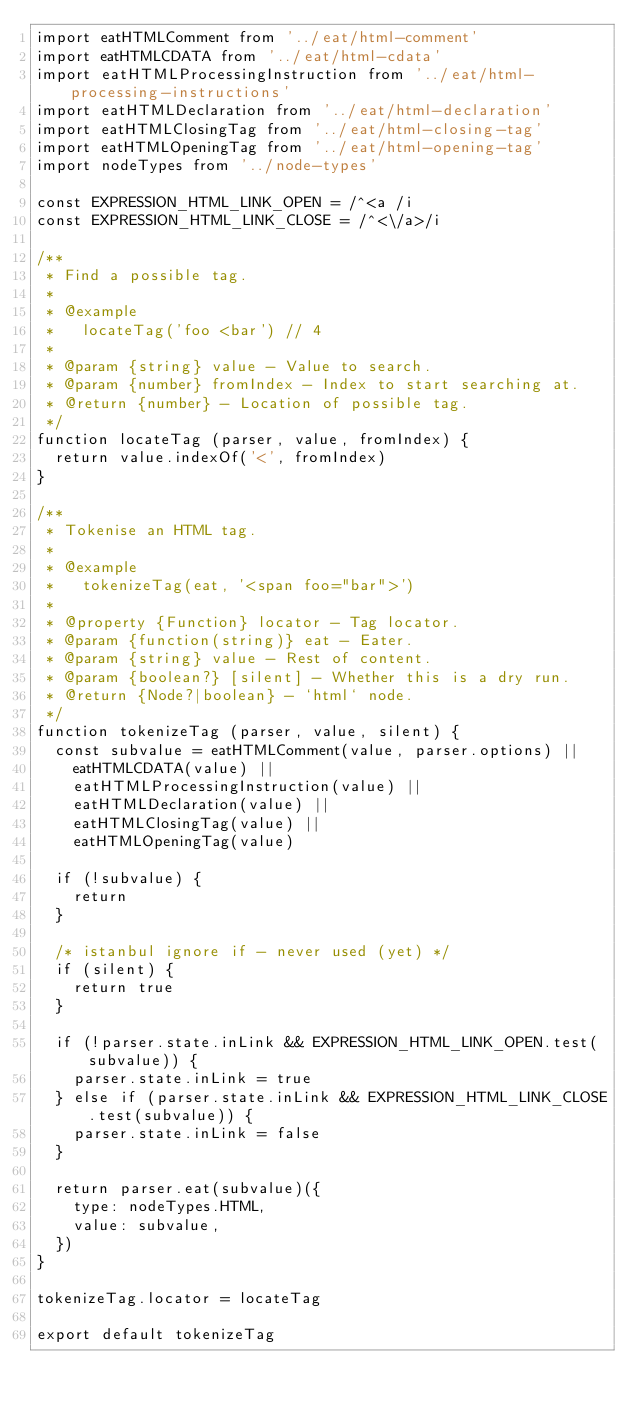<code> <loc_0><loc_0><loc_500><loc_500><_JavaScript_>import eatHTMLComment from '../eat/html-comment'
import eatHTMLCDATA from '../eat/html-cdata'
import eatHTMLProcessingInstruction from '../eat/html-processing-instructions'
import eatHTMLDeclaration from '../eat/html-declaration'
import eatHTMLClosingTag from '../eat/html-closing-tag'
import eatHTMLOpeningTag from '../eat/html-opening-tag'
import nodeTypes from '../node-types'

const EXPRESSION_HTML_LINK_OPEN = /^<a /i
const EXPRESSION_HTML_LINK_CLOSE = /^<\/a>/i

/**
 * Find a possible tag.
 *
 * @example
 *   locateTag('foo <bar') // 4
 *
 * @param {string} value - Value to search.
 * @param {number} fromIndex - Index to start searching at.
 * @return {number} - Location of possible tag.
 */
function locateTag (parser, value, fromIndex) {
  return value.indexOf('<', fromIndex)
}

/**
 * Tokenise an HTML tag.
 *
 * @example
 *   tokenizeTag(eat, '<span foo="bar">')
 *
 * @property {Function} locator - Tag locator.
 * @param {function(string)} eat - Eater.
 * @param {string} value - Rest of content.
 * @param {boolean?} [silent] - Whether this is a dry run.
 * @return {Node?|boolean} - `html` node.
 */
function tokenizeTag (parser, value, silent) {
  const subvalue = eatHTMLComment(value, parser.options) ||
    eatHTMLCDATA(value) ||
    eatHTMLProcessingInstruction(value) ||
    eatHTMLDeclaration(value) ||
    eatHTMLClosingTag(value) ||
    eatHTMLOpeningTag(value)

  if (!subvalue) {
    return
  }

  /* istanbul ignore if - never used (yet) */
  if (silent) {
    return true
  }

  if (!parser.state.inLink && EXPRESSION_HTML_LINK_OPEN.test(subvalue)) {
    parser.state.inLink = true
  } else if (parser.state.inLink && EXPRESSION_HTML_LINK_CLOSE.test(subvalue)) {
    parser.state.inLink = false
  }

  return parser.eat(subvalue)({
    type: nodeTypes.HTML,
    value: subvalue,
  })
}

tokenizeTag.locator = locateTag

export default tokenizeTag
</code> 